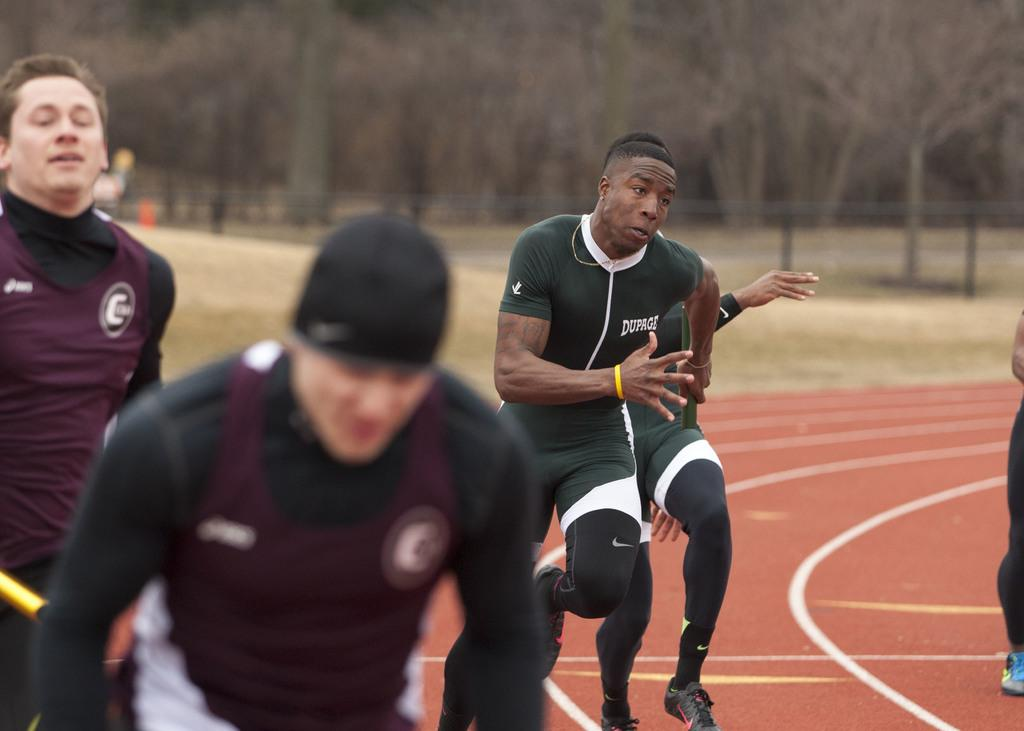What is happening in the image involving a group of people? There is a group of people in the image, and they are running on a track. What can be seen in the background of the image? There are trees in the background of the image. What type of sound can be heard coming from the plants in the image? There are no plants present in the image, and therefore no sounds can be heard from them. 